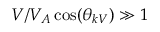Convert formula to latex. <formula><loc_0><loc_0><loc_500><loc_500>V / V _ { A } \cos ( \theta _ { k V } ) \gg 1</formula> 